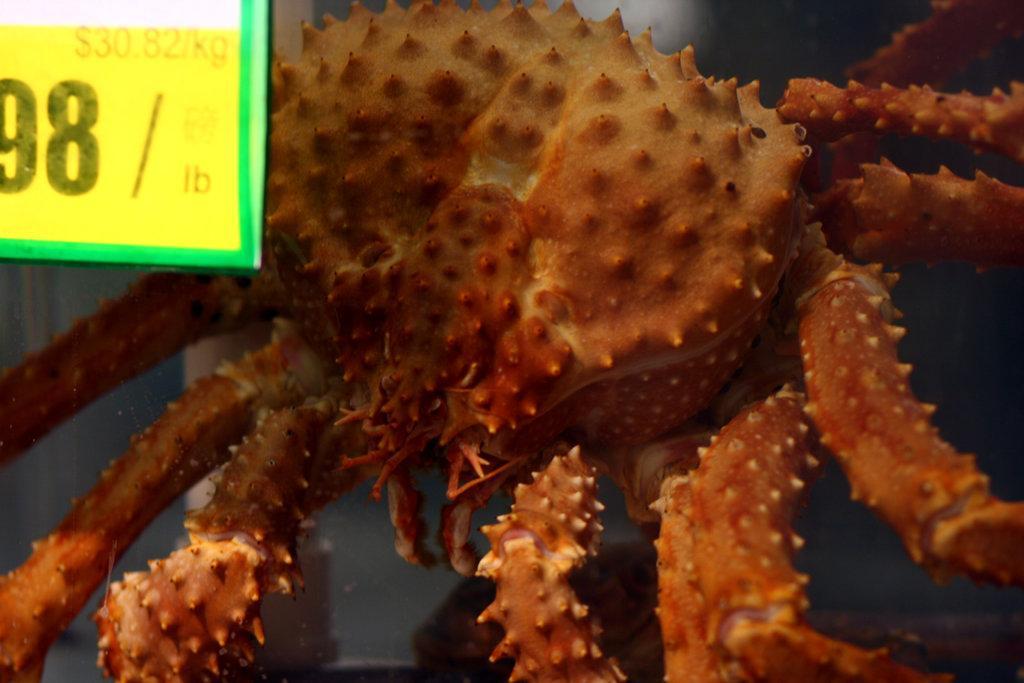Describe this image in one or two sentences. This picture looks like a crab and I can see a price board on the top left corner. 